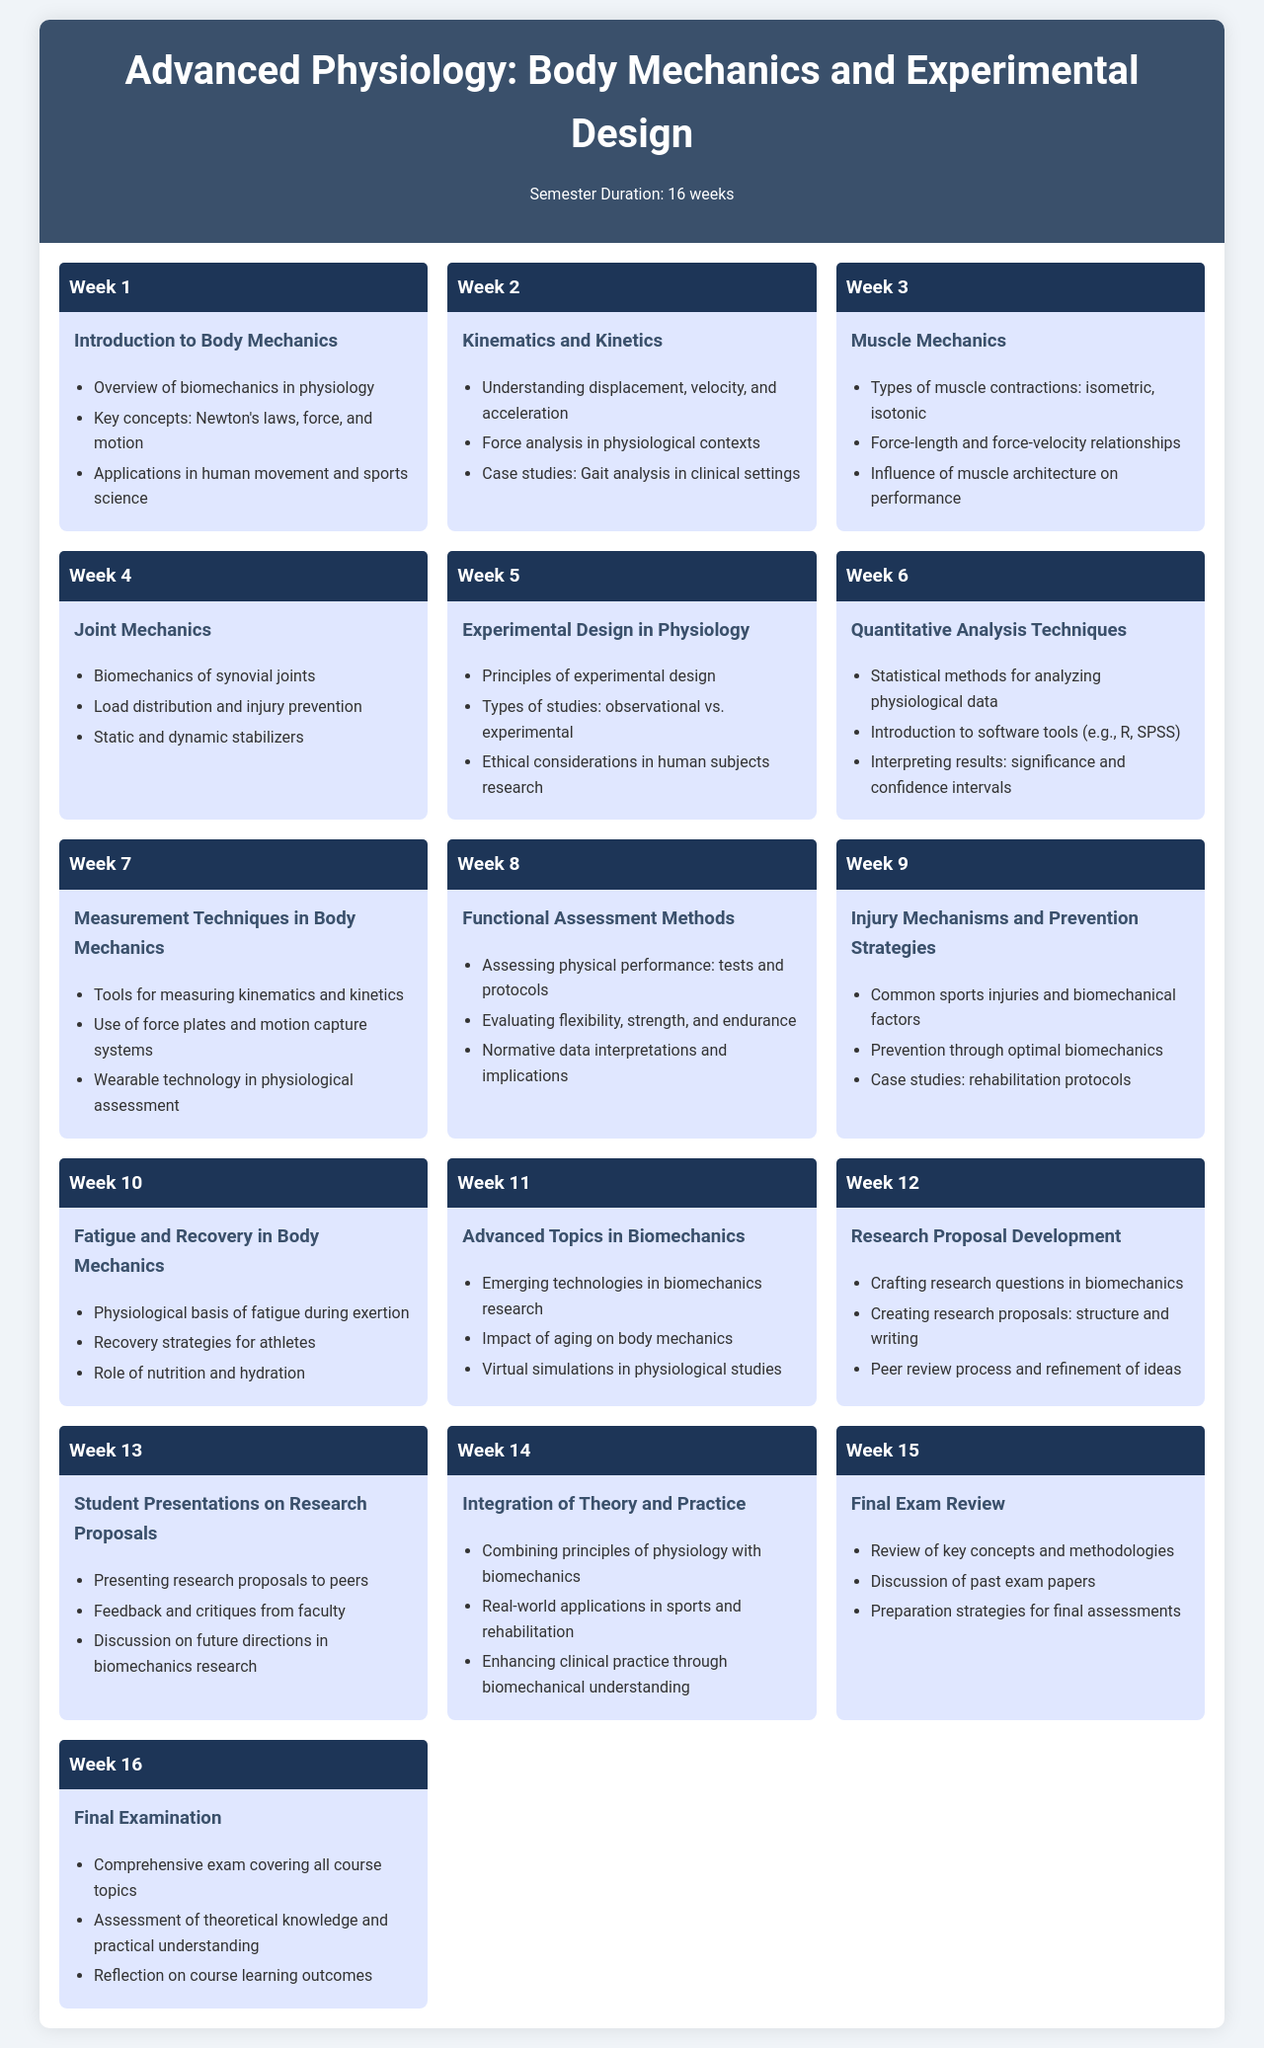What is the duration of the semester? The document specifies the semester duration as 16 weeks.
Answer: 16 weeks What are the key concepts introduced in Week 1? Week 1 covers an overview of biomechanics in physiology and includes key concepts such as Newton's laws, force, and motion.
Answer: Newton's laws, force, and motion Which week focuses on "Experimental Design in Physiology"? From the schedule, "Experimental Design in Physiology" is covered in Week 5.
Answer: Week 5 How many topics are discussed under "Measurement Techniques in Body Mechanics"? The document lists three topics under this section, including tools for measuring kinematics and kinetics.
Answer: 3 topics What is one type of muscle contraction discussed in Week 3? Week 3 mentions isometric muscle contractions as one type.
Answer: Isometric In which week are students expected to present their research proposals? According to the schedule, student presentations on research proposals take place in Week 13.
Answer: Week 13 What is the primary focus of Week 8? Week 8 is dedicated to "Functional Assessment Methods".
Answer: Functional Assessment Methods What role do force plates play in the curriculum? The document states that force plates are tools used for measuring kinematics and kinetics in Week 7.
Answer: Measuring kinematics and kinetics 